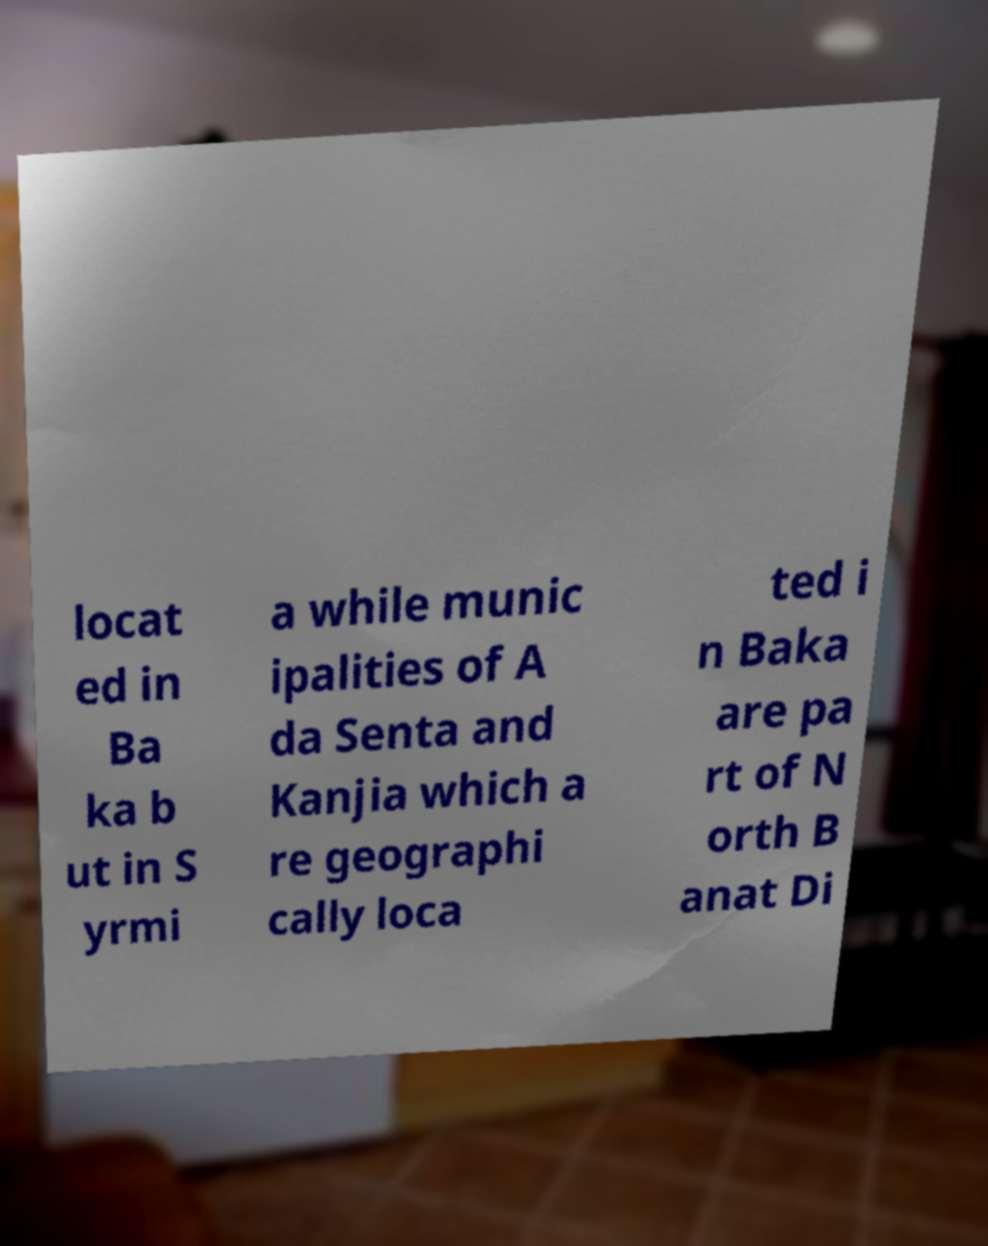There's text embedded in this image that I need extracted. Can you transcribe it verbatim? locat ed in Ba ka b ut in S yrmi a while munic ipalities of A da Senta and Kanjia which a re geographi cally loca ted i n Baka are pa rt of N orth B anat Di 